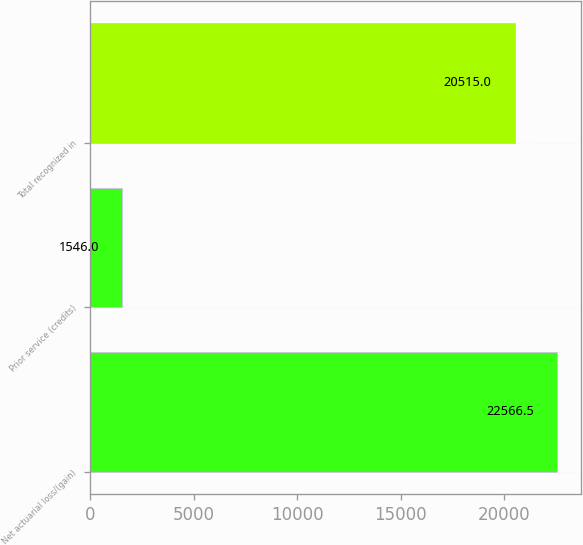Convert chart to OTSL. <chart><loc_0><loc_0><loc_500><loc_500><bar_chart><fcel>Net actuarial loss/(gain)<fcel>Prior service (credits)<fcel>Total recognized in<nl><fcel>22566.5<fcel>1546<fcel>20515<nl></chart> 